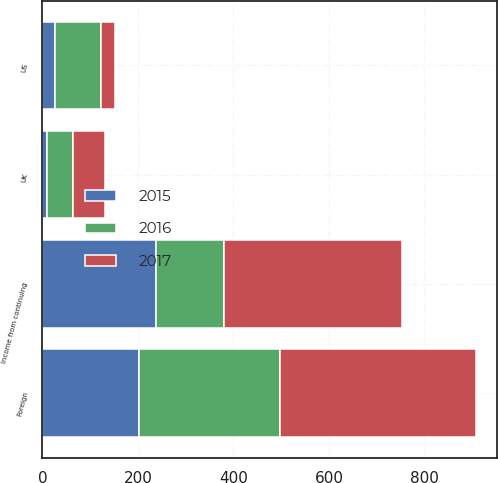Convert chart to OTSL. <chart><loc_0><loc_0><loc_500><loc_500><stacked_bar_chart><ecel><fcel>UK<fcel>US<fcel>Foreign<fcel>Income from continuing<nl><fcel>2017<fcel>67<fcel>28.7<fcel>410.4<fcel>372.1<nl><fcel>2016<fcel>55.4<fcel>96.4<fcel>294.1<fcel>142.3<nl><fcel>2015<fcel>8.9<fcel>26.1<fcel>202.8<fcel>237.8<nl></chart> 